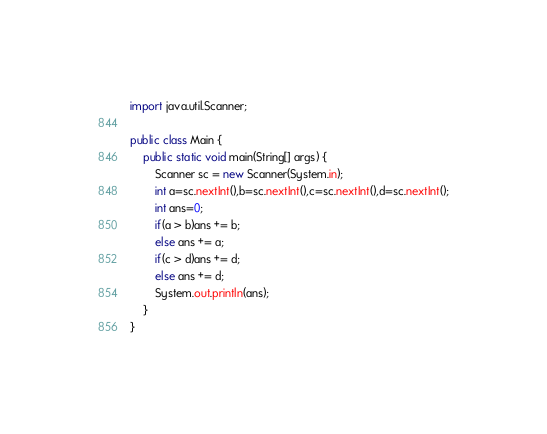<code> <loc_0><loc_0><loc_500><loc_500><_Java_>import java.util.Scanner;

public class Main {
	public static void main(String[] args) {
		Scanner sc = new Scanner(System.in);
		int a=sc.nextInt(),b=sc.nextInt(),c=sc.nextInt(),d=sc.nextInt();
		int ans=0;
		if(a > b)ans += b;
		else ans += a;
		if(c > d)ans += d;
		else ans += d;
		System.out.println(ans);
	}
}</code> 